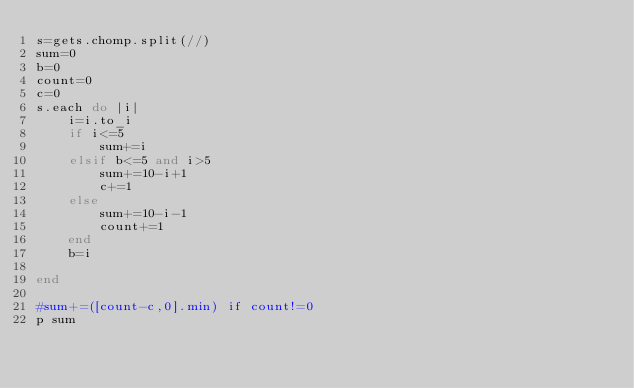<code> <loc_0><loc_0><loc_500><loc_500><_Ruby_>s=gets.chomp.split(//)
sum=0
b=0
count=0
c=0
s.each do |i|
    i=i.to_i
    if i<=5
        sum+=i 
    elsif b<=5 and i>5
        sum+=10-i+1
        c+=1
    else
        sum+=10-i-1
        count+=1
    end
    b=i
    
end

#sum+=([count-c,0].min) if count!=0
p sum

</code> 